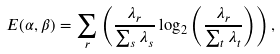<formula> <loc_0><loc_0><loc_500><loc_500>E ( \alpha , \beta ) = \sum _ { r } \left ( \frac { \lambda _ { r } } { \sum _ { s } \lambda _ { s } } \log _ { 2 } \left ( \frac { \lambda _ { r } } { \sum _ { t } \lambda _ { t } } \right ) \right ) ,</formula> 